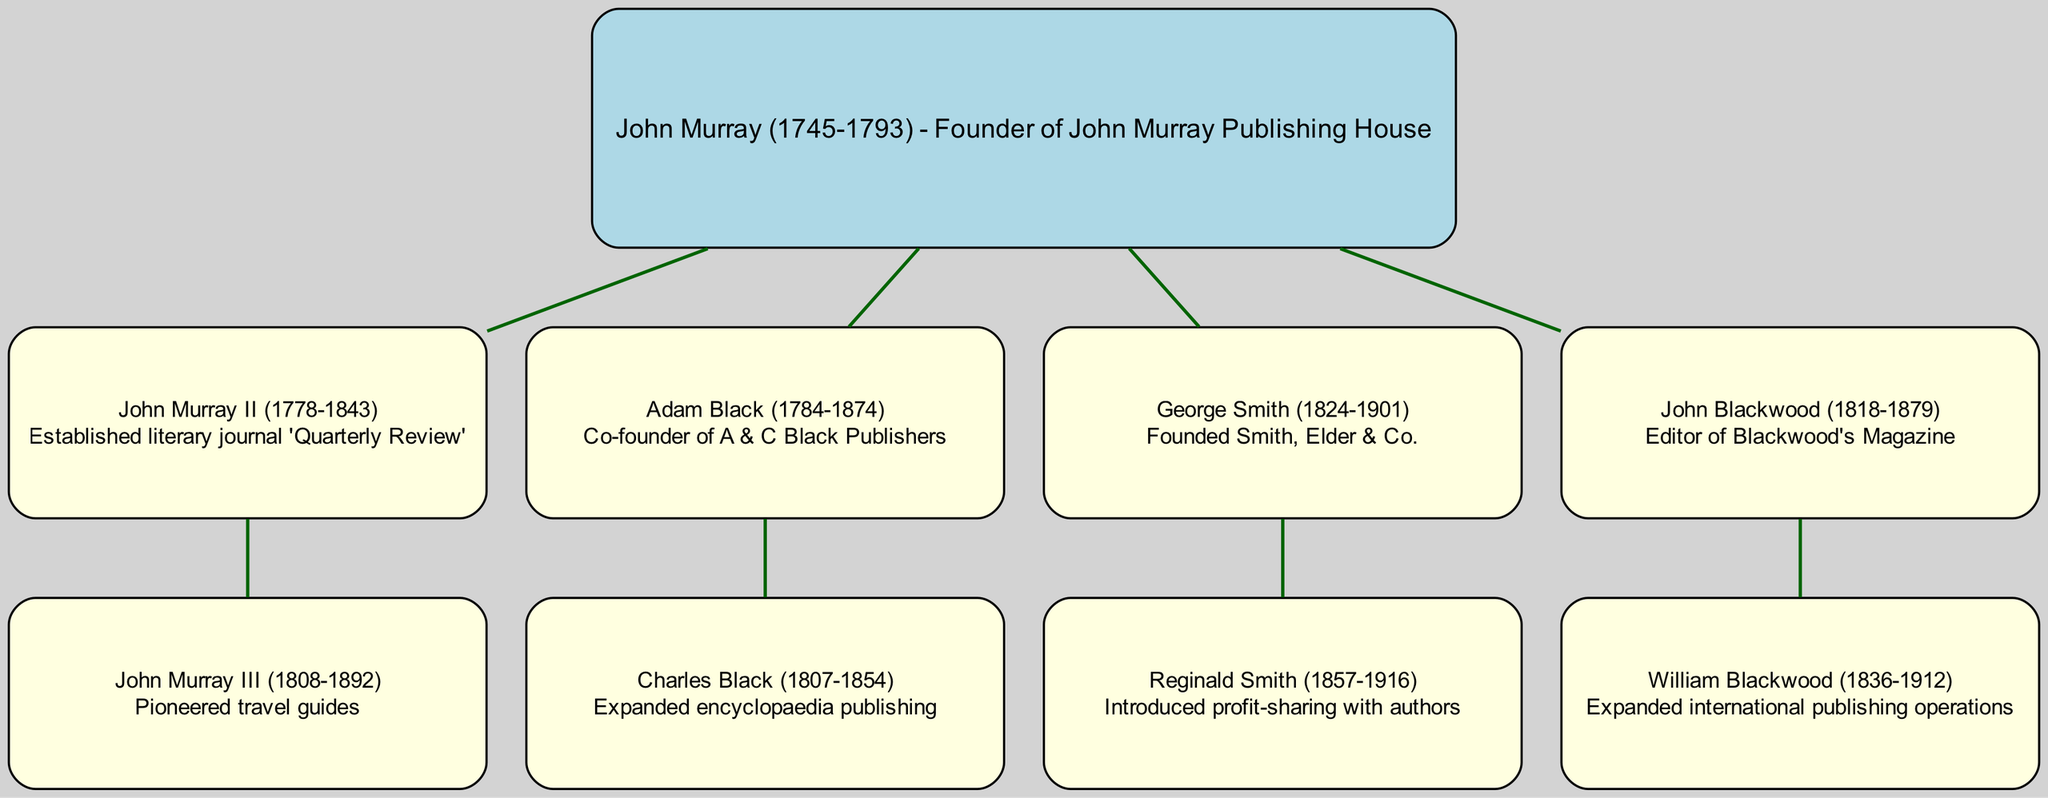What is the primary contribution of John Murray? John Murray is noted for founding John Murray Publishing House, which is a significant contribution to the publishing industry. This information can be found by looking at the root node of the diagram, which provides details about his role.
Answer: Founder of John Murray Publishing House How many children does John Murray II have? According to the diagram, John Murray II has one child, John Murray III. This can be seen by looking at the children section under John Murray II.
Answer: One Who is known for pioneering travel guides? John Murray III is recognized for pioneering travel guides, as indicated in the diagram under his node that describes his specific contribution.
Answer: John Murray III What relationship does Reginald Smith have to George Smith? Reginald Smith is the child of George Smith, as identified in the diagram by the hierarchical structure showing George Smith as the parent node with Reginald Smith as a child node connected below.
Answer: Child What significant change did Reginald Smith introduce in publishing? Reginald Smith introduced profit-sharing with authors, which is mentioned in the description associated with his node in the diagram.
Answer: Profit-sharing with authors How many different publishing companies are represented in the diagram? The diagram represents three different publishing companies: John Murray Publishing House, A & C Black Publishers, and Smith, Elder & Co. This can be counted by identifying the main contributors and their companies as indicated in each section of the tree.
Answer: Three Which individual expanded encyclopaedia publishing? Charles Black is the individual credited with expanding encyclopaedia publishing, as described within his node in the diagram.
Answer: Charles Black What is the direct contribution of Adam Black? Adam Black is noted as the co-founder of A & C Black Publishers, as described in his respective node in the diagram.
Answer: Co-founder of A & C Black Publishers Who expanded international publishing operations? William Blackwood expanded international publishing operations, as indicated in his node in the diagram which defines his contributions.
Answer: William Blackwood 